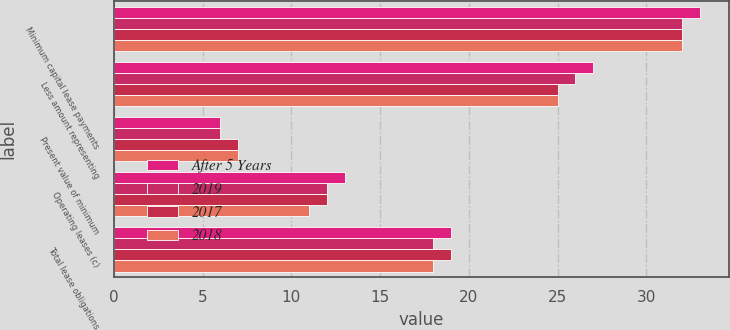Convert chart to OTSL. <chart><loc_0><loc_0><loc_500><loc_500><stacked_bar_chart><ecel><fcel>Minimum capital lease payments<fcel>Less amount representing<fcel>Present value of minimum<fcel>Operating leases (c)<fcel>Total lease obligations<nl><fcel>After 5 Years<fcel>33<fcel>27<fcel>6<fcel>13<fcel>19<nl><fcel>2019<fcel>32<fcel>26<fcel>6<fcel>12<fcel>18<nl><fcel>2017<fcel>32<fcel>25<fcel>7<fcel>12<fcel>19<nl><fcel>2018<fcel>32<fcel>25<fcel>7<fcel>11<fcel>18<nl></chart> 